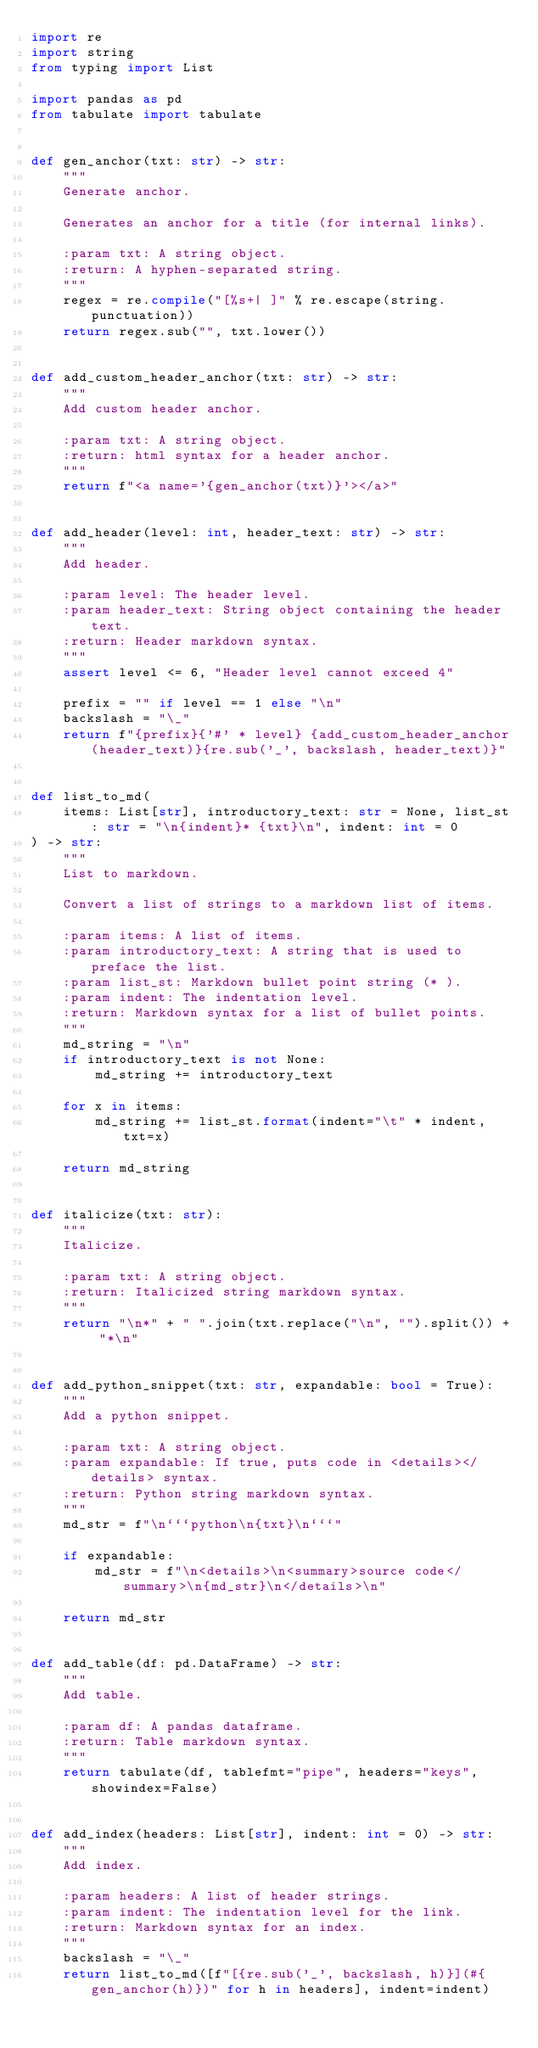<code> <loc_0><loc_0><loc_500><loc_500><_Python_>import re
import string
from typing import List

import pandas as pd
from tabulate import tabulate


def gen_anchor(txt: str) -> str:
    """
    Generate anchor.

    Generates an anchor for a title (for internal links).

    :param txt: A string object.
    :return: A hyphen-separated string.
    """
    regex = re.compile("[%s+| ]" % re.escape(string.punctuation))
    return regex.sub("", txt.lower())


def add_custom_header_anchor(txt: str) -> str:
    """
    Add custom header anchor.

    :param txt: A string object.
    :return: html syntax for a header anchor.
    """
    return f"<a name='{gen_anchor(txt)}'></a>"


def add_header(level: int, header_text: str) -> str:
    """
    Add header.

    :param level: The header level.
    :param header_text: String object containing the header text.
    :return: Header markdown syntax.
    """
    assert level <= 6, "Header level cannot exceed 4"

    prefix = "" if level == 1 else "\n"
    backslash = "\_"
    return f"{prefix}{'#' * level} {add_custom_header_anchor(header_text)}{re.sub('_', backslash, header_text)}"


def list_to_md(
    items: List[str], introductory_text: str = None, list_st: str = "\n{indent}* {txt}\n", indent: int = 0
) -> str:
    """
    List to markdown.

    Convert a list of strings to a markdown list of items.

    :param items: A list of items.
    :param introductory_text: A string that is used to preface the list.
    :param list_st: Markdown bullet point string (* ).
    :param indent: The indentation level.
    :return: Markdown syntax for a list of bullet points.
    """
    md_string = "\n"
    if introductory_text is not None:
        md_string += introductory_text

    for x in items:
        md_string += list_st.format(indent="\t" * indent, txt=x)

    return md_string


def italicize(txt: str):
    """
    Italicize.

    :param txt: A string object.
    :return: Italicized string markdown syntax.
    """
    return "\n*" + " ".join(txt.replace("\n", "").split()) + "*\n"


def add_python_snippet(txt: str, expandable: bool = True):
    """
    Add a python snippet.

    :param txt: A string object.
    :param expandable: If true, puts code in <details></details> syntax.
    :return: Python string markdown syntax.
    """
    md_str = f"\n```python\n{txt}\n```"

    if expandable:
        md_str = f"\n<details>\n<summary>source code</summary>\n{md_str}\n</details>\n"

    return md_str


def add_table(df: pd.DataFrame) -> str:
    """
    Add table.

    :param df: A pandas dataframe.
    :return: Table markdown syntax.
    """
    return tabulate(df, tablefmt="pipe", headers="keys", showindex=False)


def add_index(headers: List[str], indent: int = 0) -> str:
    """
    Add index.

    :param headers: A list of header strings.
    :param indent: The indentation level for the link.
    :return: Markdown syntax for an index.
    """
    backslash = "\_"
    return list_to_md([f"[{re.sub('_', backslash, h)}](#{gen_anchor(h)})" for h in headers], indent=indent)
</code> 